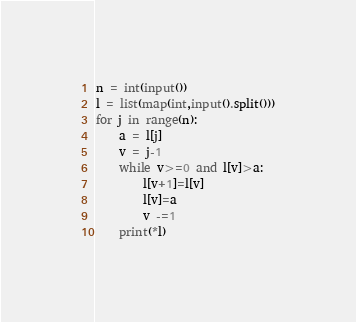Convert code to text. <code><loc_0><loc_0><loc_500><loc_500><_Python_>n = int(input())
l = list(map(int,input().split()))
for j in range(n):
    a = l[j]
    v = j-1
    while v>=0 and l[v]>a:
        l[v+1]=l[v]
        l[v]=a
        v -=1
    print(*l)
</code> 